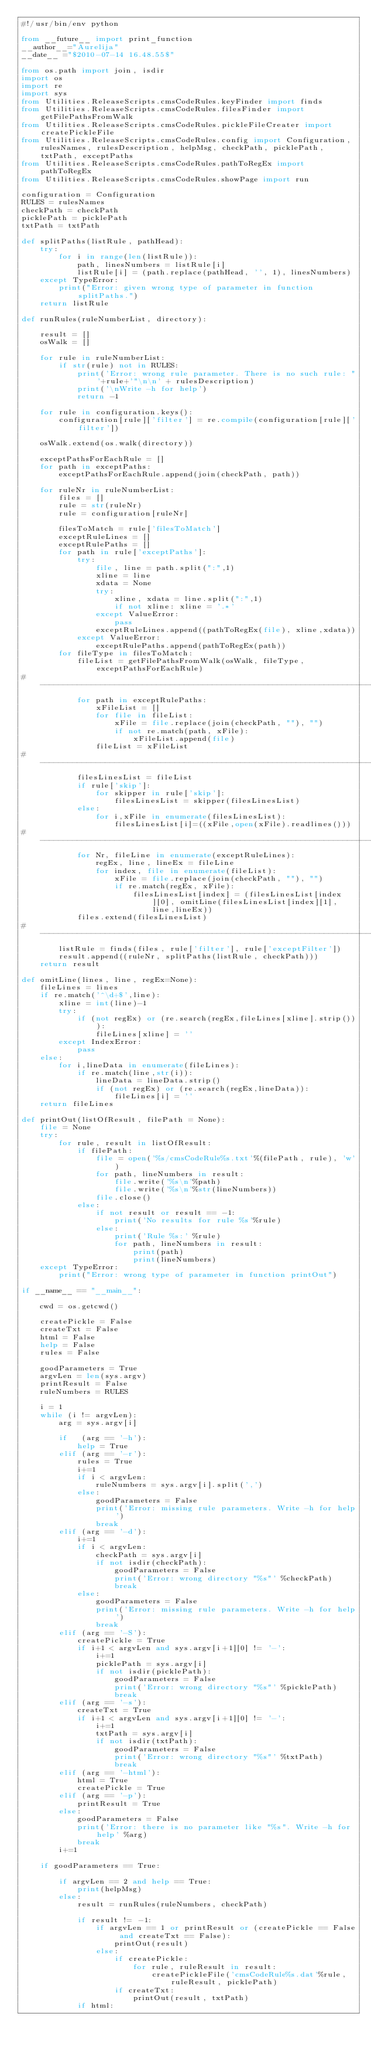<code> <loc_0><loc_0><loc_500><loc_500><_Python_>#!/usr/bin/env python

from __future__ import print_function
__author__="Aurelija"
__date__ ="$2010-07-14 16.48.55$"

from os.path import join, isdir
import os
import re
import sys
from Utilities.ReleaseScripts.cmsCodeRules.keyFinder import finds
from Utilities.ReleaseScripts.cmsCodeRules.filesFinder import getFilePathsFromWalk
from Utilities.ReleaseScripts.cmsCodeRules.pickleFileCreater import createPickleFile
from Utilities.ReleaseScripts.cmsCodeRules.config import Configuration, rulesNames, rulesDescription, helpMsg, checkPath, picklePath, txtPath, exceptPaths
from Utilities.ReleaseScripts.cmsCodeRules.pathToRegEx import pathToRegEx
from Utilities.ReleaseScripts.cmsCodeRules.showPage import run

configuration = Configuration
RULES = rulesNames
checkPath = checkPath
picklePath = picklePath
txtPath = txtPath

def splitPaths(listRule, pathHead):
    try:
        for i in range(len(listRule)):
            path, linesNumbers = listRule[i]
            listRule[i] = (path.replace(pathHead, '', 1), linesNumbers)
    except TypeError:
        print("Error: given wrong type of parameter in function splitPaths.")
    return listRule

def runRules(ruleNumberList, directory):

    result = []
    osWalk = []
    
    for rule in ruleNumberList:
        if str(rule) not in RULES:
            print('Error: wrong rule parameter. There is no such rule: "'+rule+'"\n\n' + rulesDescription)
            print('\nWrite -h for help')
            return -1

    for rule in configuration.keys():
        configuration[rule]['filter'] = re.compile(configuration[rule]['filter'])

    osWalk.extend(os.walk(directory))

    exceptPathsForEachRule = []
    for path in exceptPaths:
        exceptPathsForEachRule.append(join(checkPath, path))

    for ruleNr in ruleNumberList:
        files = []
        rule = str(ruleNr)
        rule = configuration[ruleNr]

        filesToMatch = rule['filesToMatch']
        exceptRuleLines = []
        exceptRulePaths = []
        for path in rule['exceptPaths']:
            try:
                file, line = path.split(":",1)
                xline = line
                xdata = None
                try:
                    xline, xdata = line.split(":",1)
                    if not xline: xline = '.*'
                except ValueError:
                    pass
                exceptRuleLines.append((pathToRegEx(file), xline,xdata))
            except ValueError:
                exceptRulePaths.append(pathToRegEx(path))
        for fileType in filesToMatch:
            fileList = getFilePathsFromWalk(osWalk, fileType, exceptPathsForEachRule)
# ------------------------------------------------------------------------------
            for path in exceptRulePaths:
                xFileList = []
                for file in fileList:
                    xFile = file.replace(join(checkPath, ""), "")
                    if not re.match(path, xFile):
                        xFileList.append(file)
                fileList = xFileList
# ------------------------------------------------------------------------------
            filesLinesList = fileList
            if rule['skip']:
                for skipper in rule['skip']:
                    filesLinesList = skipper(filesLinesList)
            else:
                for i,xFile in enumerate(filesLinesList):
                    filesLinesList[i]=((xFile,open(xFile).readlines()))
# ------------------------------------------------------------------------------
            for Nr, fileLine in enumerate(exceptRuleLines):
                regEx, line, lineEx = fileLine
                for index, file in enumerate(fileList):
                    xFile = file.replace(join(checkPath, ""), "")
                    if re.match(regEx, xFile):
                        filesLinesList[index] = (filesLinesList[index][0], omitLine(filesLinesList[index][1], line,lineEx))
            files.extend(filesLinesList)
# ------------------------------------------------------------------------------
        listRule = finds(files, rule['filter'], rule['exceptFilter'])
        result.append((ruleNr, splitPaths(listRule, checkPath)))
    return result

def omitLine(lines, line, regEx=None):
    fileLines = lines
    if re.match('^\d+$',line):
        xline = int(line)-1
        try:
            if (not regEx) or (re.search(regEx,fileLines[xline].strip())):
                fileLines[xline] = ''
        except IndexError:
            pass
    else:
        for i,lineData in enumerate(fileLines):
            if re.match(line,str(i)):
                lineData = lineData.strip()
                if (not regEx) or (re.search(regEx,lineData)):
                    fileLines[i] = ''
    return fileLines

def printOut(listOfResult, filePath = None):
    file = None
    try:
        for rule, result in listOfResult:
            if filePath:
                file = open('%s/cmsCodeRule%s.txt'%(filePath, rule), 'w')
                for path, lineNumbers in result:
                    file.write('%s\n'%path)
                    file.write('%s\n'%str(lineNumbers))
                file.close()
            else:
                if not result or result == -1:
                    print('No results for rule %s'%rule)
                else:
                    print('Rule %s:' %rule)
                    for path, lineNumbers in result:
                        print(path)
                        print(lineNumbers)
    except TypeError:
        print("Error: wrong type of parameter in function printOut")

if __name__ == "__main__":

    cwd = os.getcwd()
    
    createPickle = False
    createTxt = False
    html = False
    help = False
    rules = False
    
    goodParameters = True
    argvLen = len(sys.argv)
    printResult = False
    ruleNumbers = RULES

    i = 1
    while (i != argvLen):
        arg = sys.argv[i]

        if   (arg == '-h'):
            help = True
        elif (arg == '-r'):
            rules = True
            i+=1
            if i < argvLen:
                ruleNumbers = sys.argv[i].split(',')
            else:
                goodParameters = False
                print('Error: missing rule parameters. Write -h for help')
                break
        elif (arg == '-d'):
            i+=1
            if i < argvLen:
                checkPath = sys.argv[i]
                if not isdir(checkPath):
                    goodParameters = False
                    print('Error: wrong directory "%s"' %checkPath)
                    break
            else:
                goodParameters = False
                print('Error: missing rule parameters. Write -h for help')
                break
        elif (arg == '-S'):
            createPickle = True
            if i+1 < argvLen and sys.argv[i+1][0] != '-':
                i+=1
                picklePath = sys.argv[i]
                if not isdir(picklePath):
                    goodParameters = False
                    print('Error: wrong directory "%s"' %picklePath)
                    break
        elif (arg == '-s'):
            createTxt = True
            if i+1 < argvLen and sys.argv[i+1][0] != '-':
                i+=1
                txtPath = sys.argv[i]
                if not isdir(txtPath):
                    goodParameters = False
                    print('Error: wrong directory "%s"' %txtPath)
                    break
        elif (arg == '-html'):
            html = True
            createPickle = True
        elif (arg == '-p'):
            printResult = True
        else:
            goodParameters = False
            print('Error: there is no parameter like "%s". Write -h for help' %arg)
            break
        i+=1

    if goodParameters == True:

        if argvLen == 2 and help == True:
            print(helpMsg)
        else:
            result = runRules(ruleNumbers, checkPath)
                    
            if result != -1:
                if argvLen == 1 or printResult or (createPickle == False and createTxt == False):
                    printOut(result)
                else:
                    if createPickle:
                        for rule, ruleResult in result:
                            createPickleFile('cmsCodeRule%s.dat'%rule, ruleResult, picklePath)
                    if createTxt:
                        printOut(result, txtPath)
            if html:</code> 